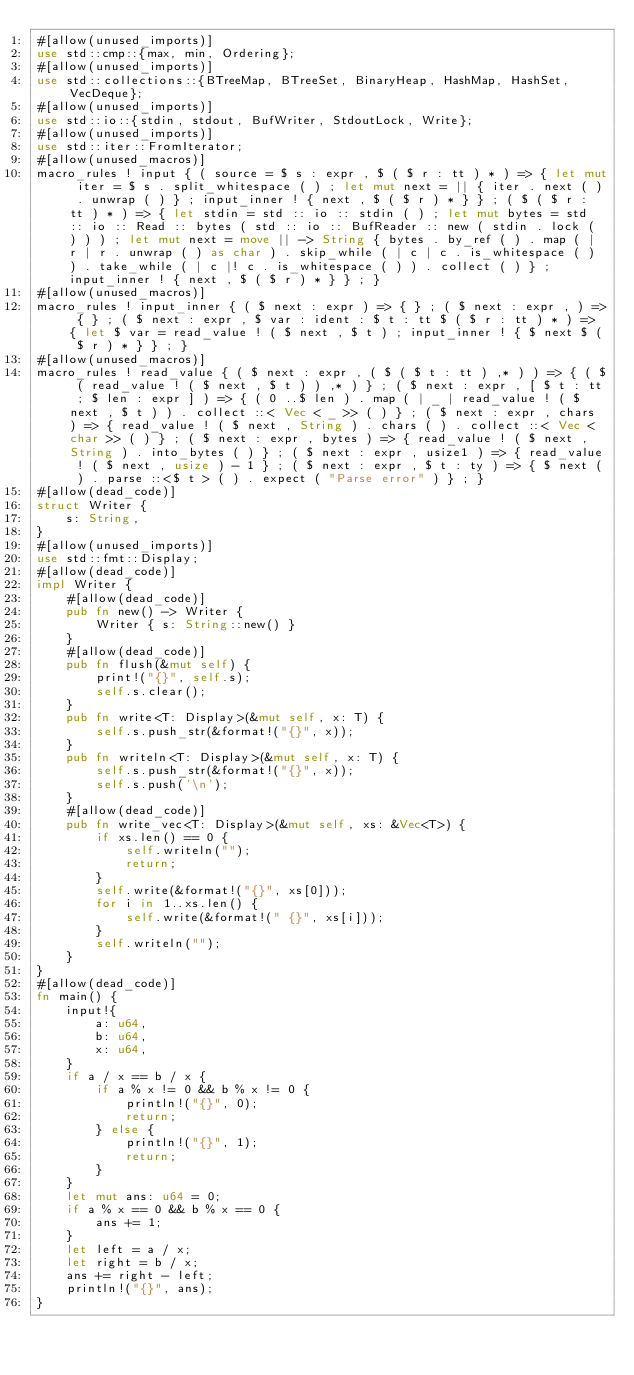<code> <loc_0><loc_0><loc_500><loc_500><_Rust_>#[allow(unused_imports)]
use std::cmp::{max, min, Ordering};
#[allow(unused_imports)]
use std::collections::{BTreeMap, BTreeSet, BinaryHeap, HashMap, HashSet, VecDeque};
#[allow(unused_imports)]
use std::io::{stdin, stdout, BufWriter, StdoutLock, Write};
#[allow(unused_imports)]
use std::iter::FromIterator;
#[allow(unused_macros)]
macro_rules ! input { ( source = $ s : expr , $ ( $ r : tt ) * ) => { let mut iter = $ s . split_whitespace ( ) ; let mut next = || { iter . next ( ) . unwrap ( ) } ; input_inner ! { next , $ ( $ r ) * } } ; ( $ ( $ r : tt ) * ) => { let stdin = std :: io :: stdin ( ) ; let mut bytes = std :: io :: Read :: bytes ( std :: io :: BufReader :: new ( stdin . lock ( ) ) ) ; let mut next = move || -> String { bytes . by_ref ( ) . map ( | r | r . unwrap ( ) as char ) . skip_while ( | c | c . is_whitespace ( ) ) . take_while ( | c |! c . is_whitespace ( ) ) . collect ( ) } ; input_inner ! { next , $ ( $ r ) * } } ; }
#[allow(unused_macros)]
macro_rules ! input_inner { ( $ next : expr ) => { } ; ( $ next : expr , ) => { } ; ( $ next : expr , $ var : ident : $ t : tt $ ( $ r : tt ) * ) => { let $ var = read_value ! ( $ next , $ t ) ; input_inner ! { $ next $ ( $ r ) * } } ; }
#[allow(unused_macros)]
macro_rules ! read_value { ( $ next : expr , ( $ ( $ t : tt ) ,* ) ) => { ( $ ( read_value ! ( $ next , $ t ) ) ,* ) } ; ( $ next : expr , [ $ t : tt ; $ len : expr ] ) => { ( 0 ..$ len ) . map ( | _ | read_value ! ( $ next , $ t ) ) . collect ::< Vec < _ >> ( ) } ; ( $ next : expr , chars ) => { read_value ! ( $ next , String ) . chars ( ) . collect ::< Vec < char >> ( ) } ; ( $ next : expr , bytes ) => { read_value ! ( $ next , String ) . into_bytes ( ) } ; ( $ next : expr , usize1 ) => { read_value ! ( $ next , usize ) - 1 } ; ( $ next : expr , $ t : ty ) => { $ next ( ) . parse ::<$ t > ( ) . expect ( "Parse error" ) } ; }
#[allow(dead_code)]
struct Writer {
    s: String,
}
#[allow(unused_imports)]
use std::fmt::Display;
#[allow(dead_code)]
impl Writer {
    #[allow(dead_code)]
    pub fn new() -> Writer {
        Writer { s: String::new() }
    }
    #[allow(dead_code)]
    pub fn flush(&mut self) {
        print!("{}", self.s);
        self.s.clear();
    }
    pub fn write<T: Display>(&mut self, x: T) {
        self.s.push_str(&format!("{}", x));
    }
    pub fn writeln<T: Display>(&mut self, x: T) {
        self.s.push_str(&format!("{}", x));
        self.s.push('\n');
    }
    #[allow(dead_code)]
    pub fn write_vec<T: Display>(&mut self, xs: &Vec<T>) {
        if xs.len() == 0 {
            self.writeln("");
            return;
        }
        self.write(&format!("{}", xs[0]));
        for i in 1..xs.len() {
            self.write(&format!(" {}", xs[i]));
        }
        self.writeln("");
    }
}
#[allow(dead_code)]
fn main() {
    input!{
        a: u64,
        b: u64,
        x: u64,
    }
    if a / x == b / x {
        if a % x != 0 && b % x != 0 {
            println!("{}", 0);
            return;
        } else {
            println!("{}", 1);
            return;
        }
    }
    let mut ans: u64 = 0;
    if a % x == 0 && b % x == 0 {
        ans += 1;
    }
    let left = a / x;
    let right = b / x;
    ans += right - left;
    println!("{}", ans);
}</code> 